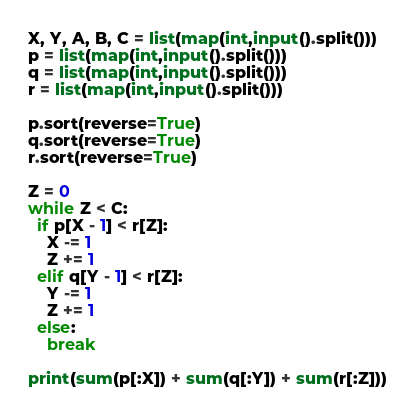Convert code to text. <code><loc_0><loc_0><loc_500><loc_500><_Python_>X, Y, A, B, C = list(map(int,input().split()))
p = list(map(int,input().split()))
q = list(map(int,input().split()))
r = list(map(int,input().split()))
 
p.sort(reverse=True)
q.sort(reverse=True)
r.sort(reverse=True)
 
Z = 0
while Z < C:
  if p[X - 1] < r[Z]:
    X -= 1
    Z += 1
  elif q[Y - 1] < r[Z]:
    Y -= 1
    Z += 1
  else:
    break
 
print(sum(p[:X]) + sum(q[:Y]) + sum(r[:Z]))</code> 